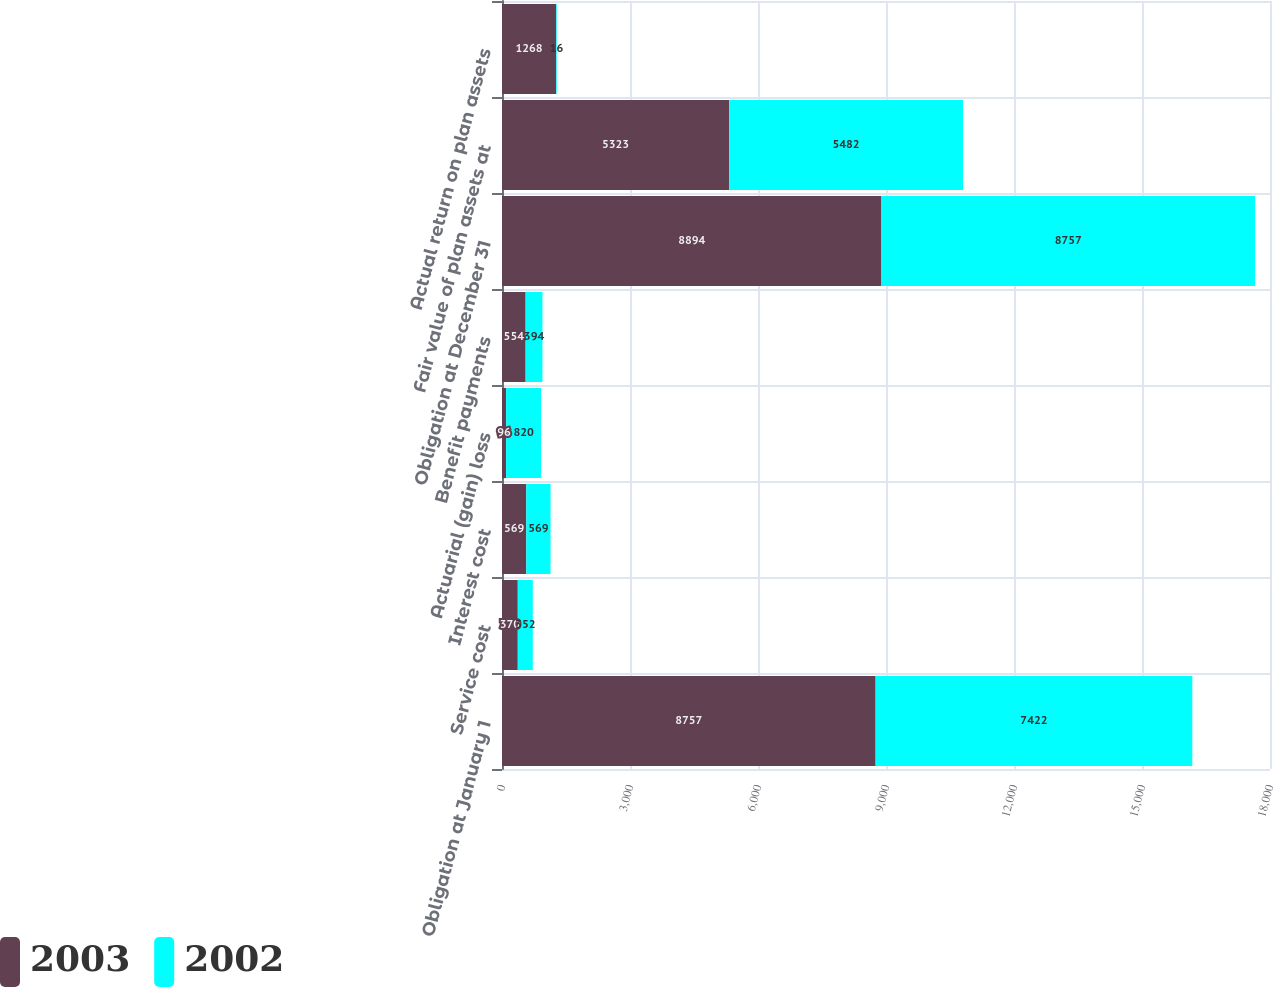Convert chart. <chart><loc_0><loc_0><loc_500><loc_500><stacked_bar_chart><ecel><fcel>Obligation at January 1<fcel>Service cost<fcel>Interest cost<fcel>Actuarial (gain) loss<fcel>Benefit payments<fcel>Obligation at December 31<fcel>Fair value of plan assets at<fcel>Actual return on plan assets<nl><fcel>2003<fcel>8757<fcel>370<fcel>569<fcel>96<fcel>554<fcel>8894<fcel>5323<fcel>1268<nl><fcel>2002<fcel>7422<fcel>352<fcel>569<fcel>820<fcel>394<fcel>8757<fcel>5482<fcel>16<nl></chart> 